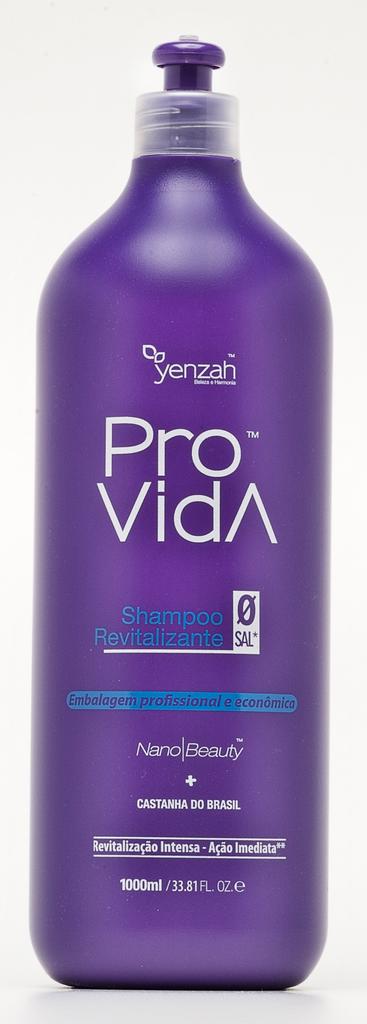How many ml in the bottle?
Your response must be concise. 1000. What is the name of the product in the purple bottle?
Give a very brief answer. Pro vida. 